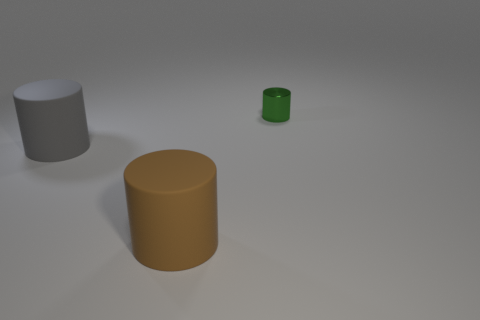Is there anything else that is made of the same material as the tiny green cylinder?
Offer a very short reply. No. Is the number of big things that are right of the big gray rubber cylinder greater than the number of tiny blue shiny balls?
Make the answer very short. Yes. Is there a brown cylinder made of the same material as the big gray thing?
Offer a very short reply. Yes. There is a object to the left of the brown matte cylinder; is its shape the same as the big brown object?
Make the answer very short. Yes. There is a large rubber cylinder on the right side of the gray object that is to the left of the large brown matte thing; how many big brown matte things are right of it?
Make the answer very short. 0. Is the number of green things in front of the large brown rubber object less than the number of things behind the gray matte cylinder?
Provide a succinct answer. Yes. The other big object that is the same shape as the brown rubber object is what color?
Your answer should be very brief. Gray. What is the size of the gray matte thing?
Your response must be concise. Large. What number of brown cylinders have the same size as the gray rubber cylinder?
Give a very brief answer. 1. Does the big thing that is to the left of the brown matte object have the same material as the green cylinder right of the brown rubber object?
Your answer should be compact. No. 